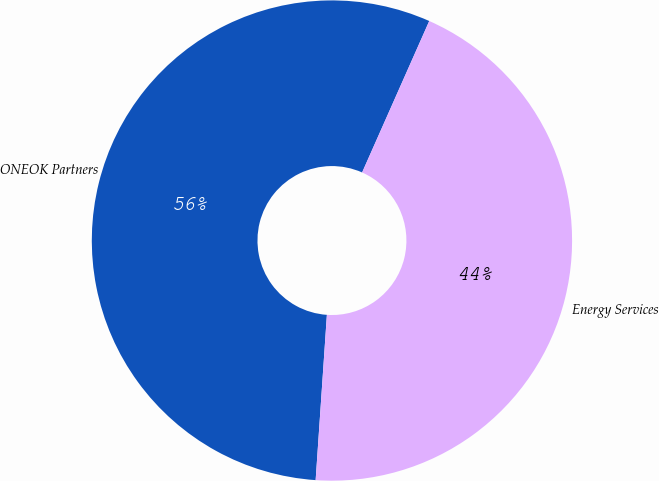Convert chart. <chart><loc_0><loc_0><loc_500><loc_500><pie_chart><fcel>ONEOK Partners<fcel>Energy Services<nl><fcel>55.56%<fcel>44.44%<nl></chart> 